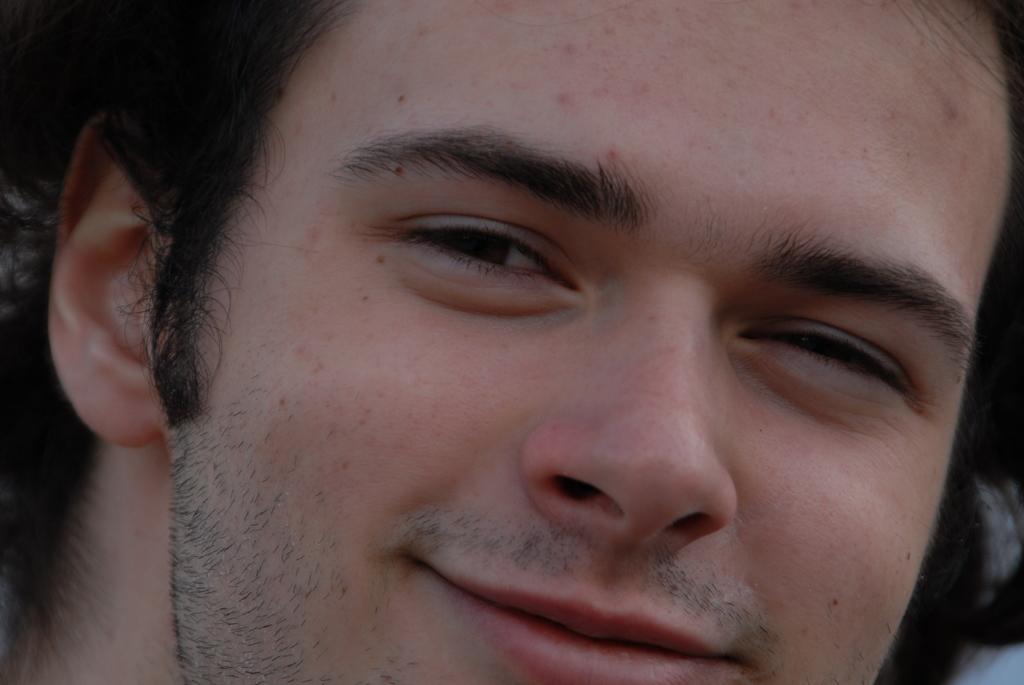Can you describe this image briefly? In this picture, we see the face of the man. He is smiling. We can only see the ear, eyes, nose and the mouth of the man. 